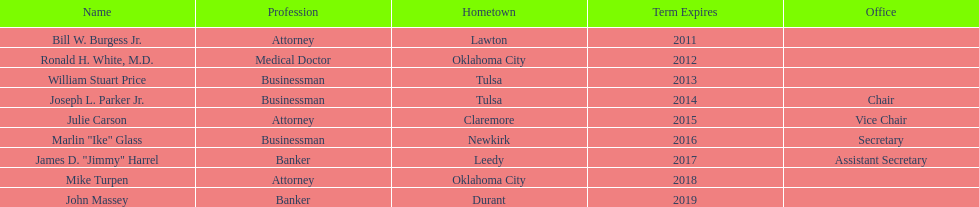Which state regent's term will last the longest? John Massey. 